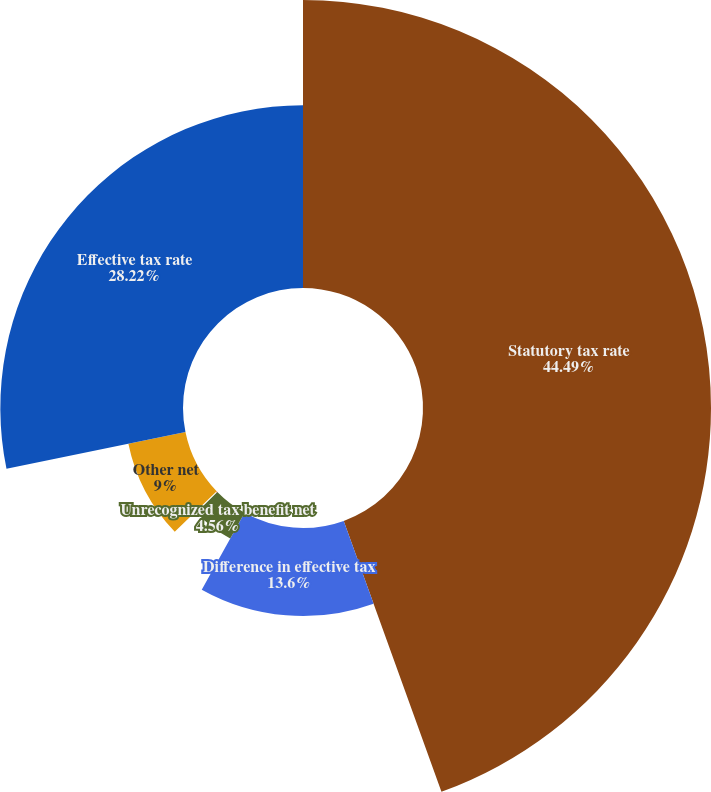<chart> <loc_0><loc_0><loc_500><loc_500><pie_chart><fcel>Statutory tax rate<fcel>Difference in effective tax<fcel>Unrecognized tax benefit net<fcel>State and local taxes<fcel>Other net<fcel>Effective tax rate<nl><fcel>44.49%<fcel>13.6%<fcel>4.56%<fcel>0.13%<fcel>9.0%<fcel>28.22%<nl></chart> 